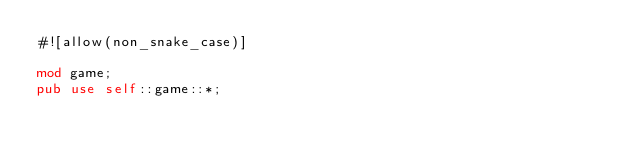<code> <loc_0><loc_0><loc_500><loc_500><_Rust_>#![allow(non_snake_case)]

mod game;
pub use self::game::*;
</code> 